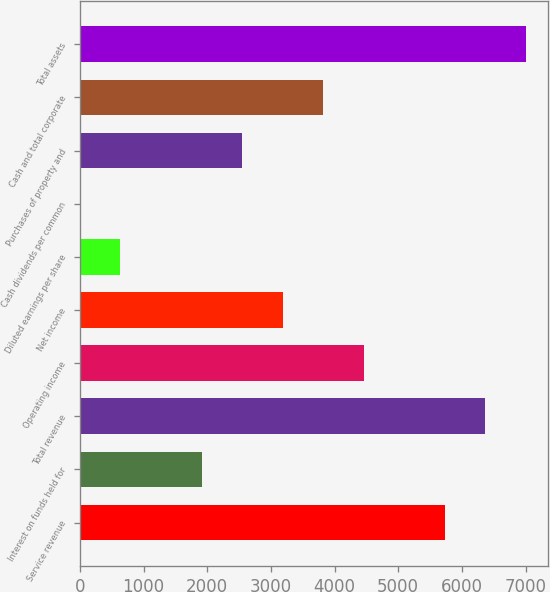<chart> <loc_0><loc_0><loc_500><loc_500><bar_chart><fcel>Service revenue<fcel>Interest on funds held for<fcel>Total revenue<fcel>Operating income<fcel>Net income<fcel>Diluted earnings per share<fcel>Cash dividends per common<fcel>Purchases of property and<fcel>Cash and total corporate<fcel>Total assets<nl><fcel>5733.23<fcel>1912.01<fcel>6370.1<fcel>4459.49<fcel>3185.75<fcel>638.27<fcel>1.4<fcel>2548.88<fcel>3822.62<fcel>7006.97<nl></chart> 